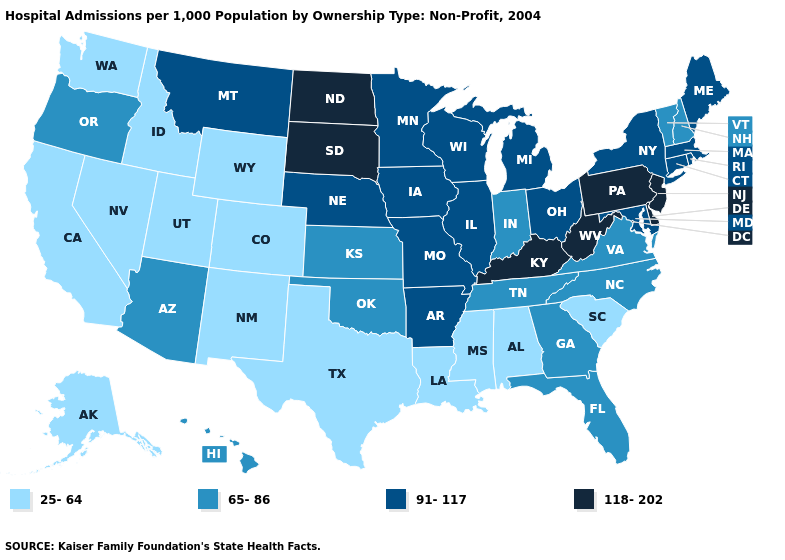What is the highest value in the USA?
Quick response, please. 118-202. Is the legend a continuous bar?
Answer briefly. No. Which states hav the highest value in the Northeast?
Write a very short answer. New Jersey, Pennsylvania. What is the lowest value in the South?
Concise answer only. 25-64. What is the value of Arkansas?
Short answer required. 91-117. Name the states that have a value in the range 65-86?
Give a very brief answer. Arizona, Florida, Georgia, Hawaii, Indiana, Kansas, New Hampshire, North Carolina, Oklahoma, Oregon, Tennessee, Vermont, Virginia. Name the states that have a value in the range 118-202?
Be succinct. Delaware, Kentucky, New Jersey, North Dakota, Pennsylvania, South Dakota, West Virginia. Name the states that have a value in the range 25-64?
Answer briefly. Alabama, Alaska, California, Colorado, Idaho, Louisiana, Mississippi, Nevada, New Mexico, South Carolina, Texas, Utah, Washington, Wyoming. Does West Virginia have the highest value in the South?
Give a very brief answer. Yes. What is the value of Texas?
Answer briefly. 25-64. What is the lowest value in the USA?
Answer briefly. 25-64. What is the value of Alabama?
Answer briefly. 25-64. What is the value of Rhode Island?
Concise answer only. 91-117. What is the value of Colorado?
Answer briefly. 25-64. Name the states that have a value in the range 25-64?
Keep it brief. Alabama, Alaska, California, Colorado, Idaho, Louisiana, Mississippi, Nevada, New Mexico, South Carolina, Texas, Utah, Washington, Wyoming. 